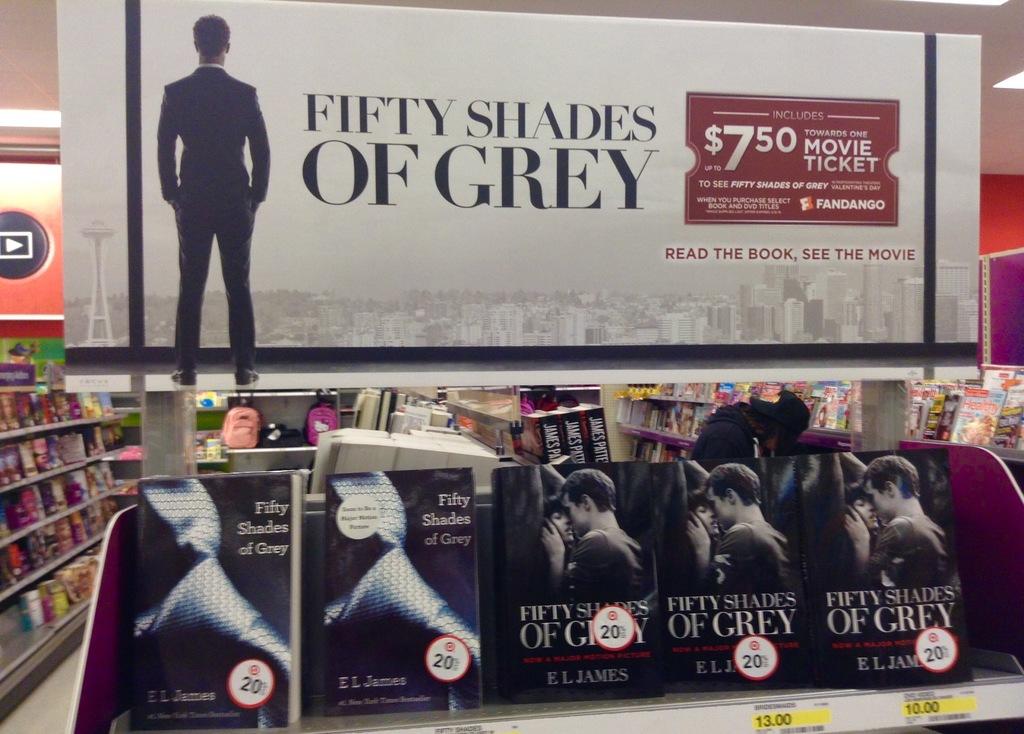How much does the movie ticket cost?
Offer a terse response. $7.50. What is the name of the book?
Ensure brevity in your answer.  Fifty shades of grey. 